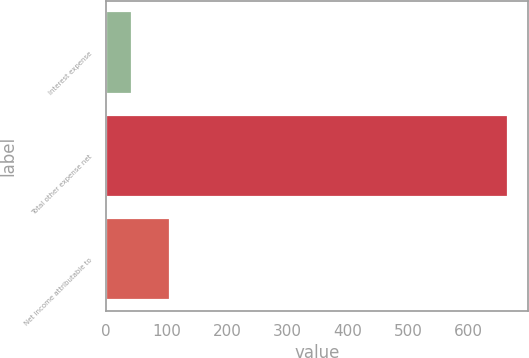Convert chart to OTSL. <chart><loc_0><loc_0><loc_500><loc_500><bar_chart><fcel>Interest expense<fcel>Total other expense net<fcel>Net income attributable to<nl><fcel>43<fcel>666<fcel>105.3<nl></chart> 